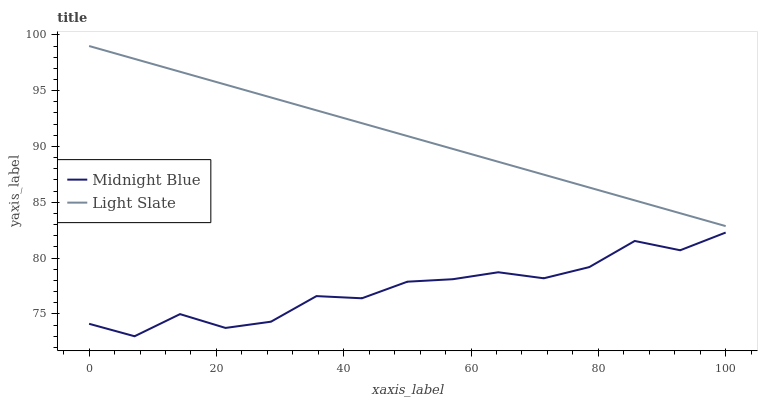Does Midnight Blue have the minimum area under the curve?
Answer yes or no. Yes. Does Light Slate have the maximum area under the curve?
Answer yes or no. Yes. Does Midnight Blue have the maximum area under the curve?
Answer yes or no. No. Is Light Slate the smoothest?
Answer yes or no. Yes. Is Midnight Blue the roughest?
Answer yes or no. Yes. Is Midnight Blue the smoothest?
Answer yes or no. No. Does Midnight Blue have the lowest value?
Answer yes or no. Yes. Does Light Slate have the highest value?
Answer yes or no. Yes. Does Midnight Blue have the highest value?
Answer yes or no. No. Is Midnight Blue less than Light Slate?
Answer yes or no. Yes. Is Light Slate greater than Midnight Blue?
Answer yes or no. Yes. Does Midnight Blue intersect Light Slate?
Answer yes or no. No. 